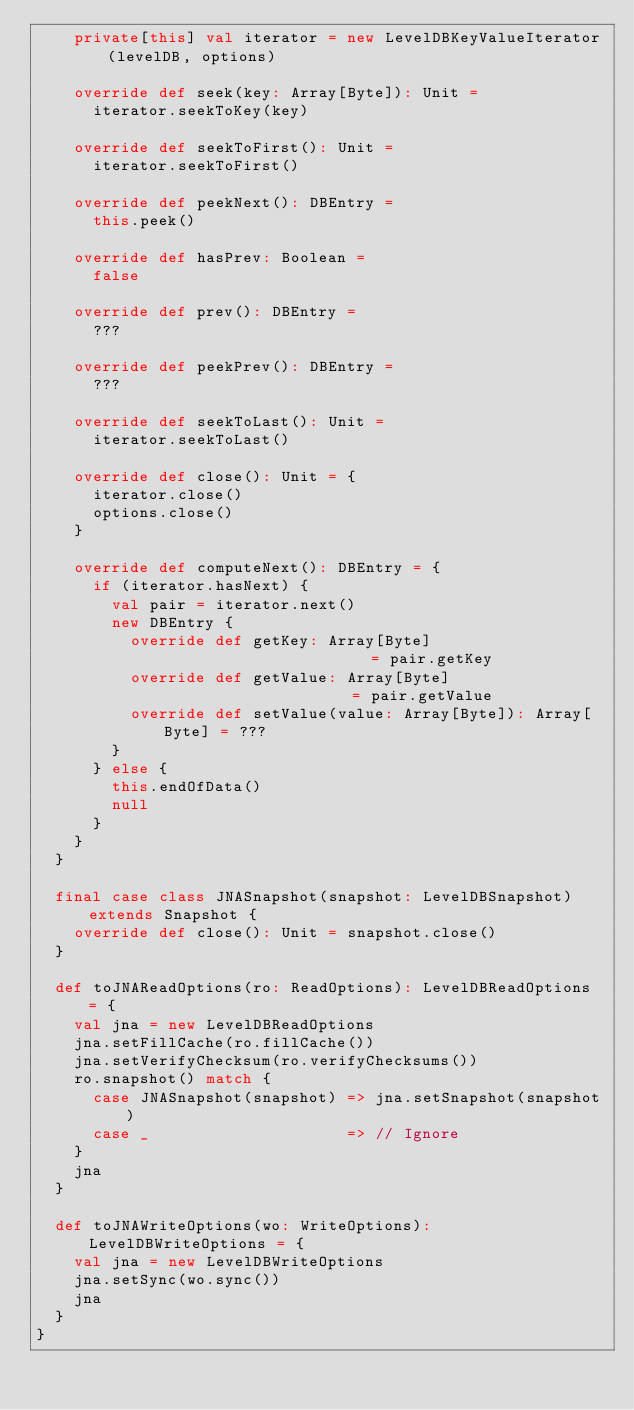<code> <loc_0><loc_0><loc_500><loc_500><_Scala_>    private[this] val iterator = new LevelDBKeyValueIterator(levelDB, options)

    override def seek(key: Array[Byte]): Unit =
      iterator.seekToKey(key)

    override def seekToFirst(): Unit =
      iterator.seekToFirst()

    override def peekNext(): DBEntry =
      this.peek()

    override def hasPrev: Boolean =
      false

    override def prev(): DBEntry =
      ???

    override def peekPrev(): DBEntry =
      ???

    override def seekToLast(): Unit =
      iterator.seekToLast()

    override def close(): Unit = {
      iterator.close()
      options.close()
    }

    override def computeNext(): DBEntry = {
      if (iterator.hasNext) {
        val pair = iterator.next()
        new DBEntry {
          override def getKey: Array[Byte]                       = pair.getKey
          override def getValue: Array[Byte]                     = pair.getValue
          override def setValue(value: Array[Byte]): Array[Byte] = ???
        }
      } else {
        this.endOfData()
        null
      }
    }
  }

  final case class JNASnapshot(snapshot: LevelDBSnapshot) extends Snapshot {
    override def close(): Unit = snapshot.close()
  }

  def toJNAReadOptions(ro: ReadOptions): LevelDBReadOptions = {
    val jna = new LevelDBReadOptions
    jna.setFillCache(ro.fillCache())
    jna.setVerifyChecksum(ro.verifyChecksums())
    ro.snapshot() match {
      case JNASnapshot(snapshot) => jna.setSnapshot(snapshot)
      case _                     => // Ignore
    }
    jna
  }

  def toJNAWriteOptions(wo: WriteOptions): LevelDBWriteOptions = {
    val jna = new LevelDBWriteOptions
    jna.setSync(wo.sync())
    jna
  }
}
</code> 